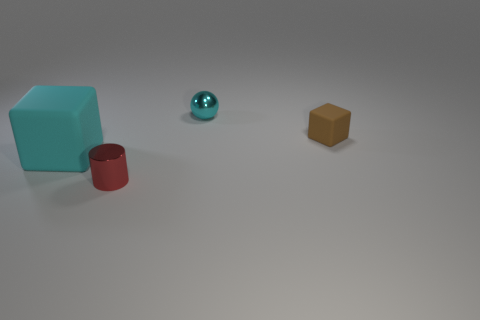Add 3 large cubes. How many objects exist? 7 Subtract all balls. How many objects are left? 3 Add 2 red shiny objects. How many red shiny objects exist? 3 Subtract 0 green blocks. How many objects are left? 4 Subtract all small metallic cylinders. Subtract all small shiny spheres. How many objects are left? 2 Add 4 red objects. How many red objects are left? 5 